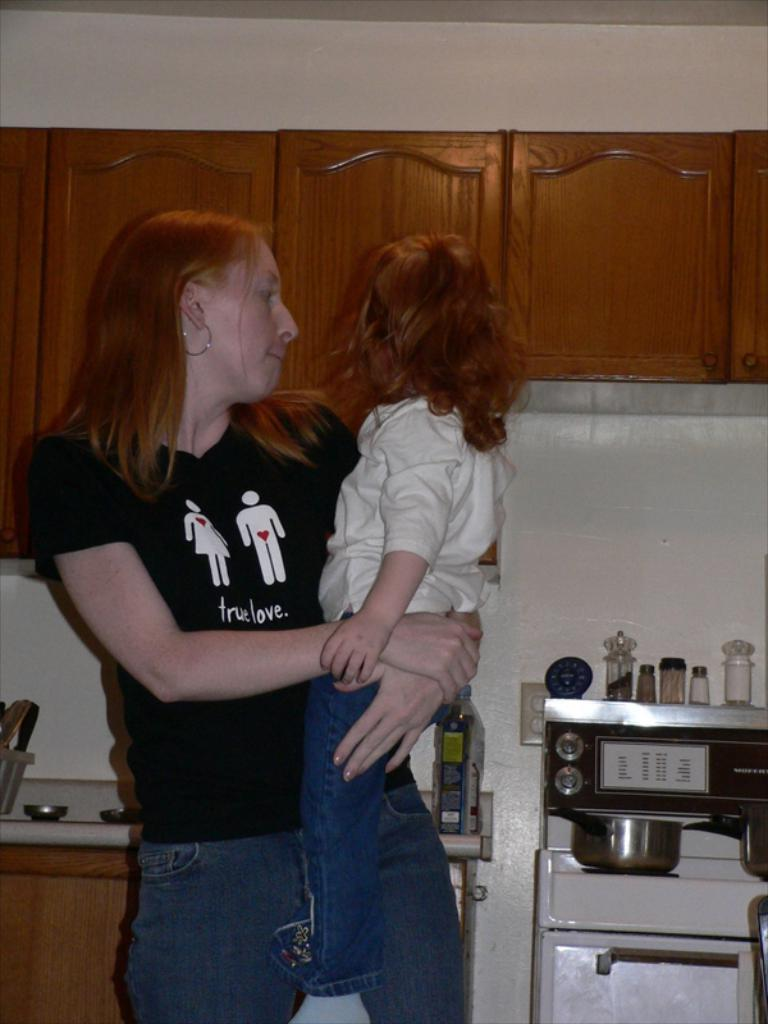<image>
Describe the image concisely. True Love is printed on this woman's t shirt. 